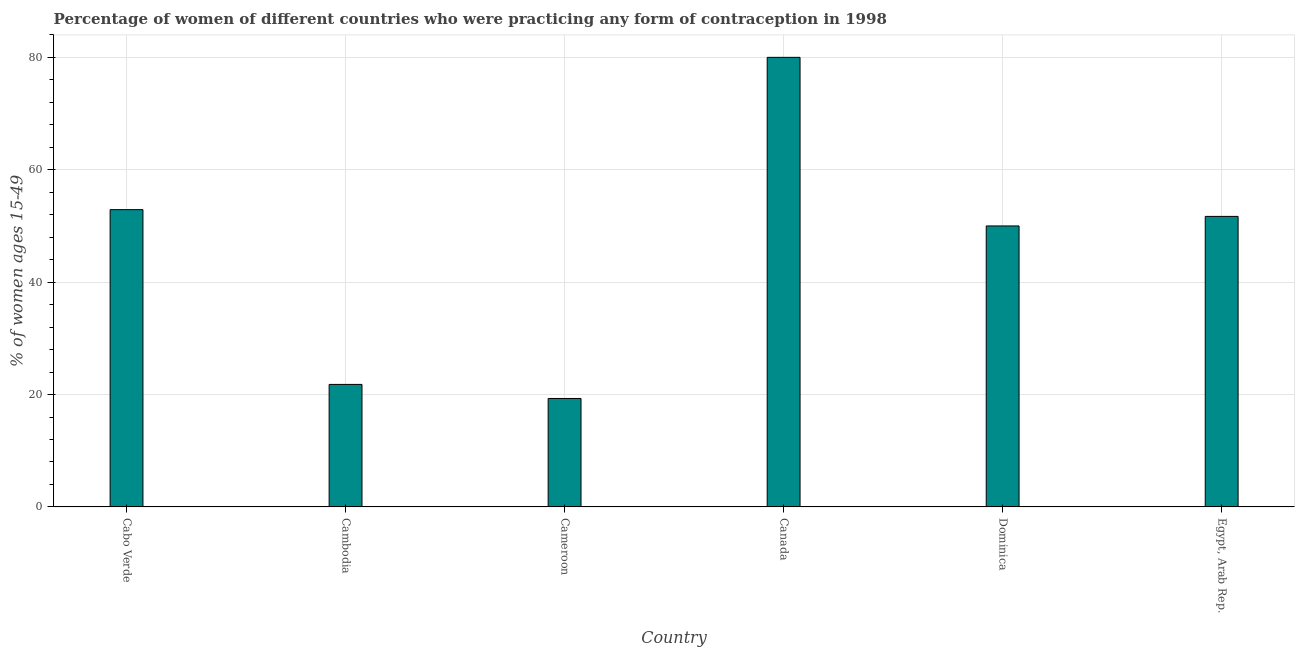What is the title of the graph?
Ensure brevity in your answer.  Percentage of women of different countries who were practicing any form of contraception in 1998. What is the label or title of the Y-axis?
Make the answer very short. % of women ages 15-49. What is the contraceptive prevalence in Cambodia?
Your response must be concise. 21.8. Across all countries, what is the maximum contraceptive prevalence?
Make the answer very short. 80. Across all countries, what is the minimum contraceptive prevalence?
Keep it short and to the point. 19.3. In which country was the contraceptive prevalence minimum?
Ensure brevity in your answer.  Cameroon. What is the sum of the contraceptive prevalence?
Your answer should be compact. 275.7. What is the difference between the contraceptive prevalence in Cabo Verde and Cameroon?
Your response must be concise. 33.6. What is the average contraceptive prevalence per country?
Your response must be concise. 45.95. What is the median contraceptive prevalence?
Offer a very short reply. 50.85. In how many countries, is the contraceptive prevalence greater than 76 %?
Make the answer very short. 1. What is the ratio of the contraceptive prevalence in Cameroon to that in Dominica?
Provide a short and direct response. 0.39. Is the difference between the contraceptive prevalence in Cabo Verde and Cambodia greater than the difference between any two countries?
Your response must be concise. No. What is the difference between the highest and the second highest contraceptive prevalence?
Your answer should be compact. 27.1. Is the sum of the contraceptive prevalence in Cabo Verde and Dominica greater than the maximum contraceptive prevalence across all countries?
Provide a short and direct response. Yes. What is the difference between the highest and the lowest contraceptive prevalence?
Ensure brevity in your answer.  60.7. How many bars are there?
Provide a short and direct response. 6. What is the difference between two consecutive major ticks on the Y-axis?
Your response must be concise. 20. What is the % of women ages 15-49 of Cabo Verde?
Ensure brevity in your answer.  52.9. What is the % of women ages 15-49 of Cambodia?
Offer a very short reply. 21.8. What is the % of women ages 15-49 of Cameroon?
Your answer should be very brief. 19.3. What is the % of women ages 15-49 of Dominica?
Ensure brevity in your answer.  50. What is the % of women ages 15-49 in Egypt, Arab Rep.?
Give a very brief answer. 51.7. What is the difference between the % of women ages 15-49 in Cabo Verde and Cambodia?
Provide a short and direct response. 31.1. What is the difference between the % of women ages 15-49 in Cabo Verde and Cameroon?
Give a very brief answer. 33.6. What is the difference between the % of women ages 15-49 in Cabo Verde and Canada?
Provide a succinct answer. -27.1. What is the difference between the % of women ages 15-49 in Cambodia and Cameroon?
Offer a very short reply. 2.5. What is the difference between the % of women ages 15-49 in Cambodia and Canada?
Your answer should be very brief. -58.2. What is the difference between the % of women ages 15-49 in Cambodia and Dominica?
Make the answer very short. -28.2. What is the difference between the % of women ages 15-49 in Cambodia and Egypt, Arab Rep.?
Keep it short and to the point. -29.9. What is the difference between the % of women ages 15-49 in Cameroon and Canada?
Provide a short and direct response. -60.7. What is the difference between the % of women ages 15-49 in Cameroon and Dominica?
Ensure brevity in your answer.  -30.7. What is the difference between the % of women ages 15-49 in Cameroon and Egypt, Arab Rep.?
Your response must be concise. -32.4. What is the difference between the % of women ages 15-49 in Canada and Dominica?
Provide a short and direct response. 30. What is the difference between the % of women ages 15-49 in Canada and Egypt, Arab Rep.?
Your response must be concise. 28.3. What is the difference between the % of women ages 15-49 in Dominica and Egypt, Arab Rep.?
Make the answer very short. -1.7. What is the ratio of the % of women ages 15-49 in Cabo Verde to that in Cambodia?
Offer a very short reply. 2.43. What is the ratio of the % of women ages 15-49 in Cabo Verde to that in Cameroon?
Make the answer very short. 2.74. What is the ratio of the % of women ages 15-49 in Cabo Verde to that in Canada?
Make the answer very short. 0.66. What is the ratio of the % of women ages 15-49 in Cabo Verde to that in Dominica?
Your answer should be compact. 1.06. What is the ratio of the % of women ages 15-49 in Cabo Verde to that in Egypt, Arab Rep.?
Make the answer very short. 1.02. What is the ratio of the % of women ages 15-49 in Cambodia to that in Cameroon?
Offer a terse response. 1.13. What is the ratio of the % of women ages 15-49 in Cambodia to that in Canada?
Offer a very short reply. 0.27. What is the ratio of the % of women ages 15-49 in Cambodia to that in Dominica?
Offer a very short reply. 0.44. What is the ratio of the % of women ages 15-49 in Cambodia to that in Egypt, Arab Rep.?
Make the answer very short. 0.42. What is the ratio of the % of women ages 15-49 in Cameroon to that in Canada?
Make the answer very short. 0.24. What is the ratio of the % of women ages 15-49 in Cameroon to that in Dominica?
Your answer should be compact. 0.39. What is the ratio of the % of women ages 15-49 in Cameroon to that in Egypt, Arab Rep.?
Provide a succinct answer. 0.37. What is the ratio of the % of women ages 15-49 in Canada to that in Egypt, Arab Rep.?
Ensure brevity in your answer.  1.55. What is the ratio of the % of women ages 15-49 in Dominica to that in Egypt, Arab Rep.?
Ensure brevity in your answer.  0.97. 